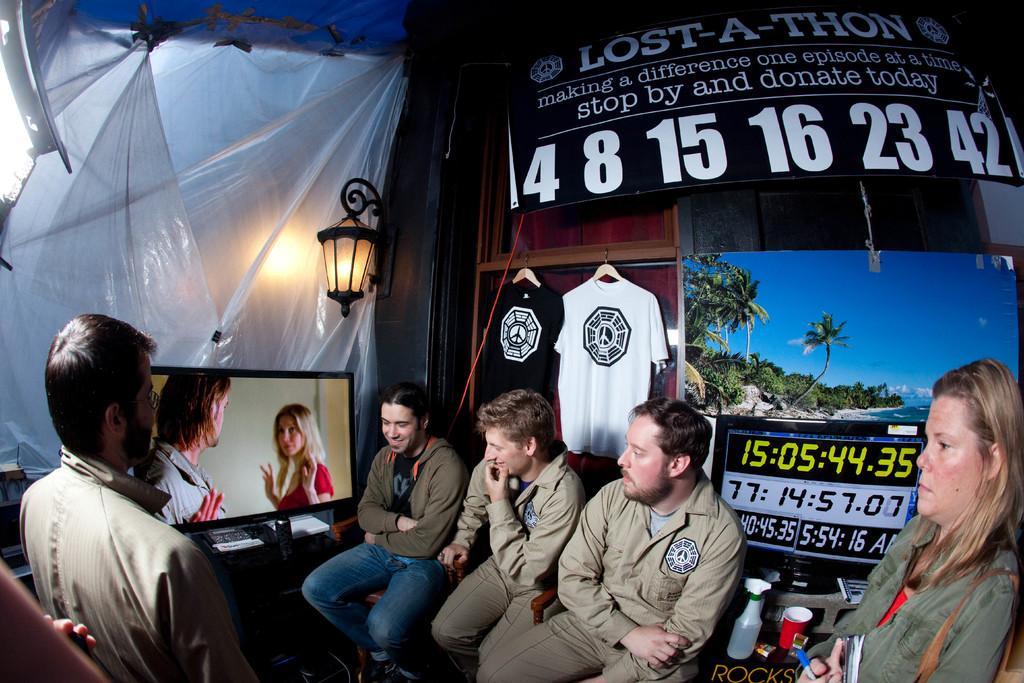In one or two sentences, can you explain what this image depicts? In this image there are a group of people sitting, and in the center there is one television. And in the background there are plastic covers, light, shirts, boards and on the boards there is text. And on the right side there is a picture of beach, trees and sky and also there is a cup, bottle and other objects. 